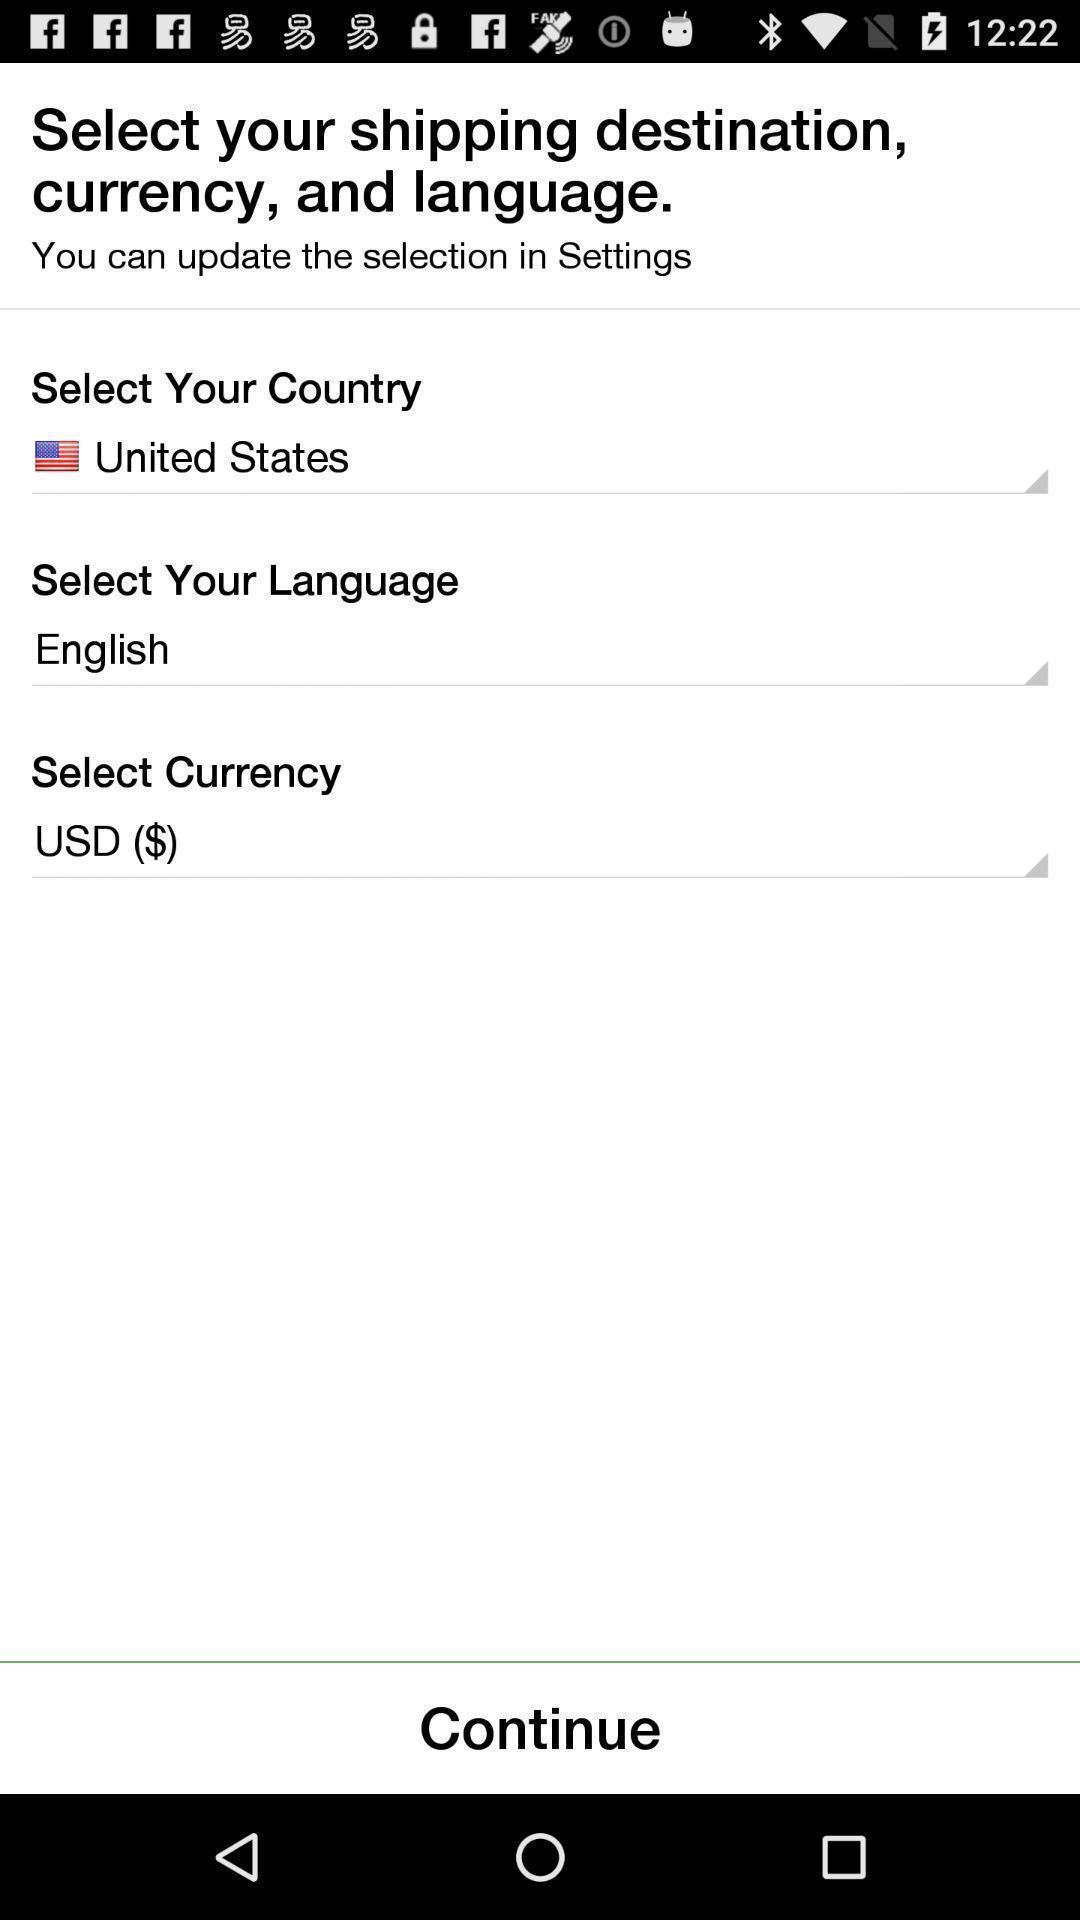What can you discern from this picture? Page shows to select shipping address for delivering the items. 